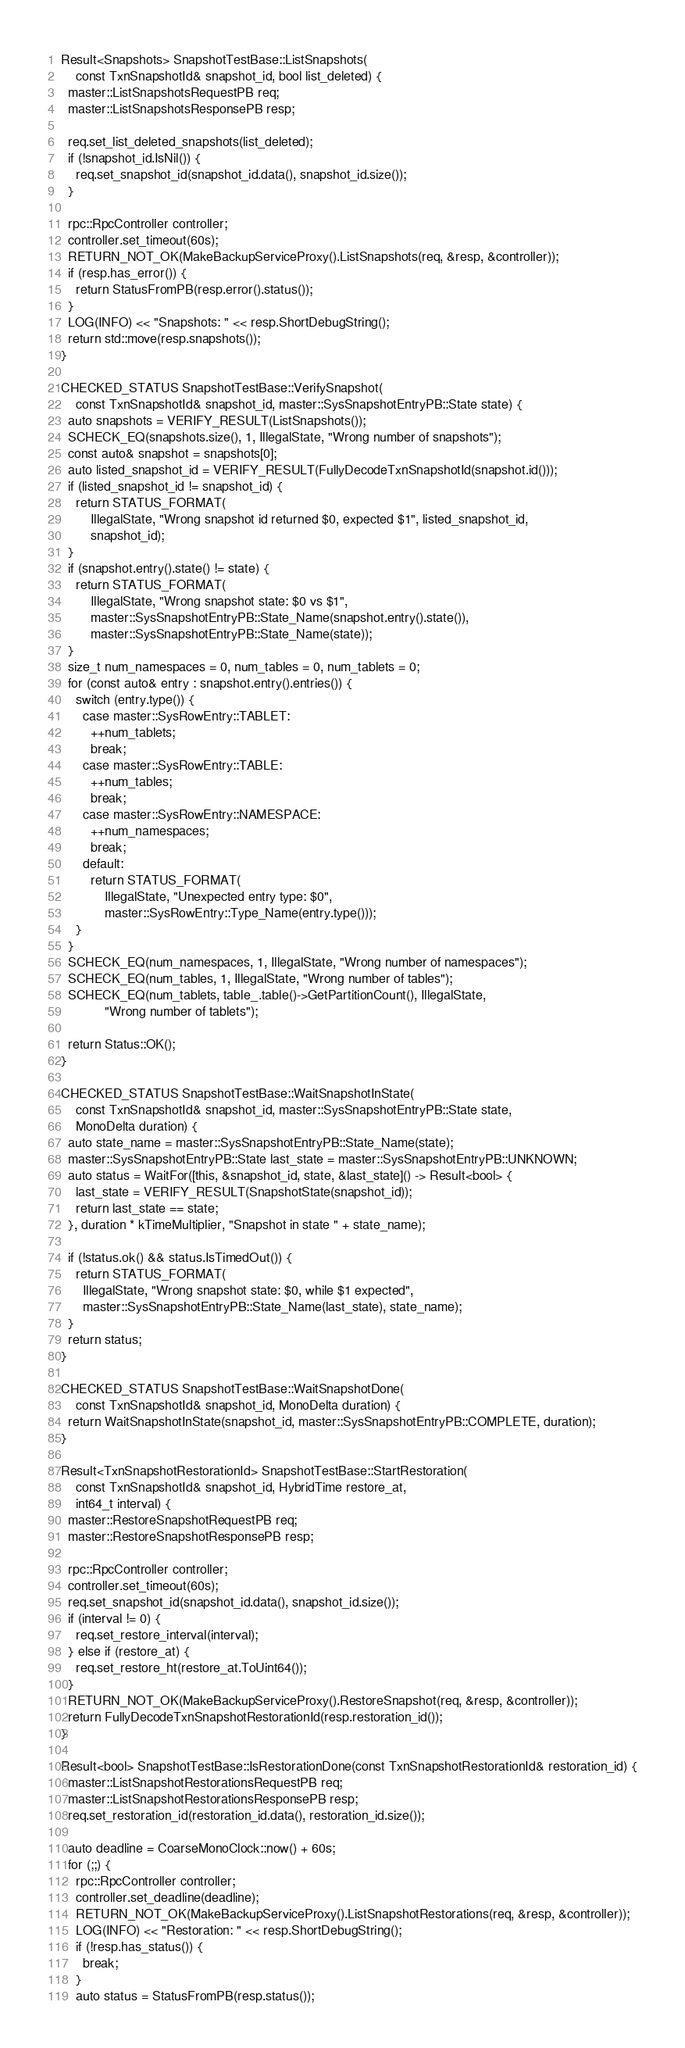<code> <loc_0><loc_0><loc_500><loc_500><_C++_>Result<Snapshots> SnapshotTestBase::ListSnapshots(
    const TxnSnapshotId& snapshot_id, bool list_deleted) {
  master::ListSnapshotsRequestPB req;
  master::ListSnapshotsResponsePB resp;

  req.set_list_deleted_snapshots(list_deleted);
  if (!snapshot_id.IsNil()) {
    req.set_snapshot_id(snapshot_id.data(), snapshot_id.size());
  }

  rpc::RpcController controller;
  controller.set_timeout(60s);
  RETURN_NOT_OK(MakeBackupServiceProxy().ListSnapshots(req, &resp, &controller));
  if (resp.has_error()) {
    return StatusFromPB(resp.error().status());
  }
  LOG(INFO) << "Snapshots: " << resp.ShortDebugString();
  return std::move(resp.snapshots());
}

CHECKED_STATUS SnapshotTestBase::VerifySnapshot(
    const TxnSnapshotId& snapshot_id, master::SysSnapshotEntryPB::State state) {
  auto snapshots = VERIFY_RESULT(ListSnapshots());
  SCHECK_EQ(snapshots.size(), 1, IllegalState, "Wrong number of snapshots");
  const auto& snapshot = snapshots[0];
  auto listed_snapshot_id = VERIFY_RESULT(FullyDecodeTxnSnapshotId(snapshot.id()));
  if (listed_snapshot_id != snapshot_id) {
    return STATUS_FORMAT(
        IllegalState, "Wrong snapshot id returned $0, expected $1", listed_snapshot_id,
        snapshot_id);
  }
  if (snapshot.entry().state() != state) {
    return STATUS_FORMAT(
        IllegalState, "Wrong snapshot state: $0 vs $1",
        master::SysSnapshotEntryPB::State_Name(snapshot.entry().state()),
        master::SysSnapshotEntryPB::State_Name(state));
  }
  size_t num_namespaces = 0, num_tables = 0, num_tablets = 0;
  for (const auto& entry : snapshot.entry().entries()) {
    switch (entry.type()) {
      case master::SysRowEntry::TABLET:
        ++num_tablets;
        break;
      case master::SysRowEntry::TABLE:
        ++num_tables;
        break;
      case master::SysRowEntry::NAMESPACE:
        ++num_namespaces;
        break;
      default:
        return STATUS_FORMAT(
            IllegalState, "Unexpected entry type: $0",
            master::SysRowEntry::Type_Name(entry.type()));
    }
  }
  SCHECK_EQ(num_namespaces, 1, IllegalState, "Wrong number of namespaces");
  SCHECK_EQ(num_tables, 1, IllegalState, "Wrong number of tables");
  SCHECK_EQ(num_tablets, table_.table()->GetPartitionCount(), IllegalState,
            "Wrong number of tablets");

  return Status::OK();
}

CHECKED_STATUS SnapshotTestBase::WaitSnapshotInState(
    const TxnSnapshotId& snapshot_id, master::SysSnapshotEntryPB::State state,
    MonoDelta duration) {
  auto state_name = master::SysSnapshotEntryPB::State_Name(state);
  master::SysSnapshotEntryPB::State last_state = master::SysSnapshotEntryPB::UNKNOWN;
  auto status = WaitFor([this, &snapshot_id, state, &last_state]() -> Result<bool> {
    last_state = VERIFY_RESULT(SnapshotState(snapshot_id));
    return last_state == state;
  }, duration * kTimeMultiplier, "Snapshot in state " + state_name);

  if (!status.ok() && status.IsTimedOut()) {
    return STATUS_FORMAT(
      IllegalState, "Wrong snapshot state: $0, while $1 expected",
      master::SysSnapshotEntryPB::State_Name(last_state), state_name);
  }
  return status;
}

CHECKED_STATUS SnapshotTestBase::WaitSnapshotDone(
    const TxnSnapshotId& snapshot_id, MonoDelta duration) {
  return WaitSnapshotInState(snapshot_id, master::SysSnapshotEntryPB::COMPLETE, duration);
}

Result<TxnSnapshotRestorationId> SnapshotTestBase::StartRestoration(
    const TxnSnapshotId& snapshot_id, HybridTime restore_at,
    int64_t interval) {
  master::RestoreSnapshotRequestPB req;
  master::RestoreSnapshotResponsePB resp;

  rpc::RpcController controller;
  controller.set_timeout(60s);
  req.set_snapshot_id(snapshot_id.data(), snapshot_id.size());
  if (interval != 0) {
    req.set_restore_interval(interval);
  } else if (restore_at) {
    req.set_restore_ht(restore_at.ToUint64());
  }
  RETURN_NOT_OK(MakeBackupServiceProxy().RestoreSnapshot(req, &resp, &controller));
  return FullyDecodeTxnSnapshotRestorationId(resp.restoration_id());
}

Result<bool> SnapshotTestBase::IsRestorationDone(const TxnSnapshotRestorationId& restoration_id) {
  master::ListSnapshotRestorationsRequestPB req;
  master::ListSnapshotRestorationsResponsePB resp;
  req.set_restoration_id(restoration_id.data(), restoration_id.size());

  auto deadline = CoarseMonoClock::now() + 60s;
  for (;;) {
    rpc::RpcController controller;
    controller.set_deadline(deadline);
    RETURN_NOT_OK(MakeBackupServiceProxy().ListSnapshotRestorations(req, &resp, &controller));
    LOG(INFO) << "Restoration: " << resp.ShortDebugString();
    if (!resp.has_status()) {
      break;
    }
    auto status = StatusFromPB(resp.status());</code> 